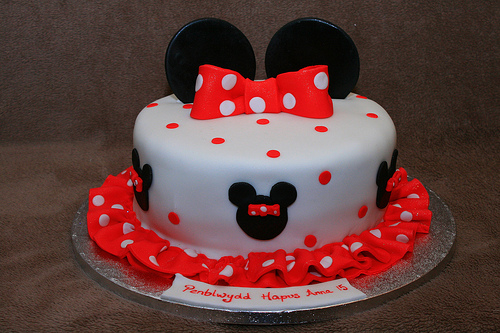<image>
Is the black circle on the cake? Yes. Looking at the image, I can see the black circle is positioned on top of the cake, with the cake providing support. Is the tie above the tray? Yes. The tie is positioned above the tray in the vertical space, higher up in the scene. 